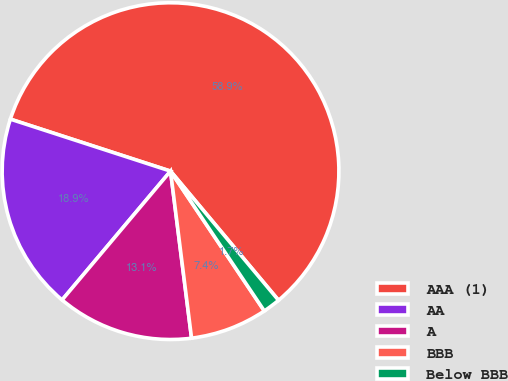Convert chart to OTSL. <chart><loc_0><loc_0><loc_500><loc_500><pie_chart><fcel>AAA (1)<fcel>AA<fcel>A<fcel>BBB<fcel>Below BBB<nl><fcel>58.92%<fcel>18.86%<fcel>13.13%<fcel>7.41%<fcel>1.68%<nl></chart> 